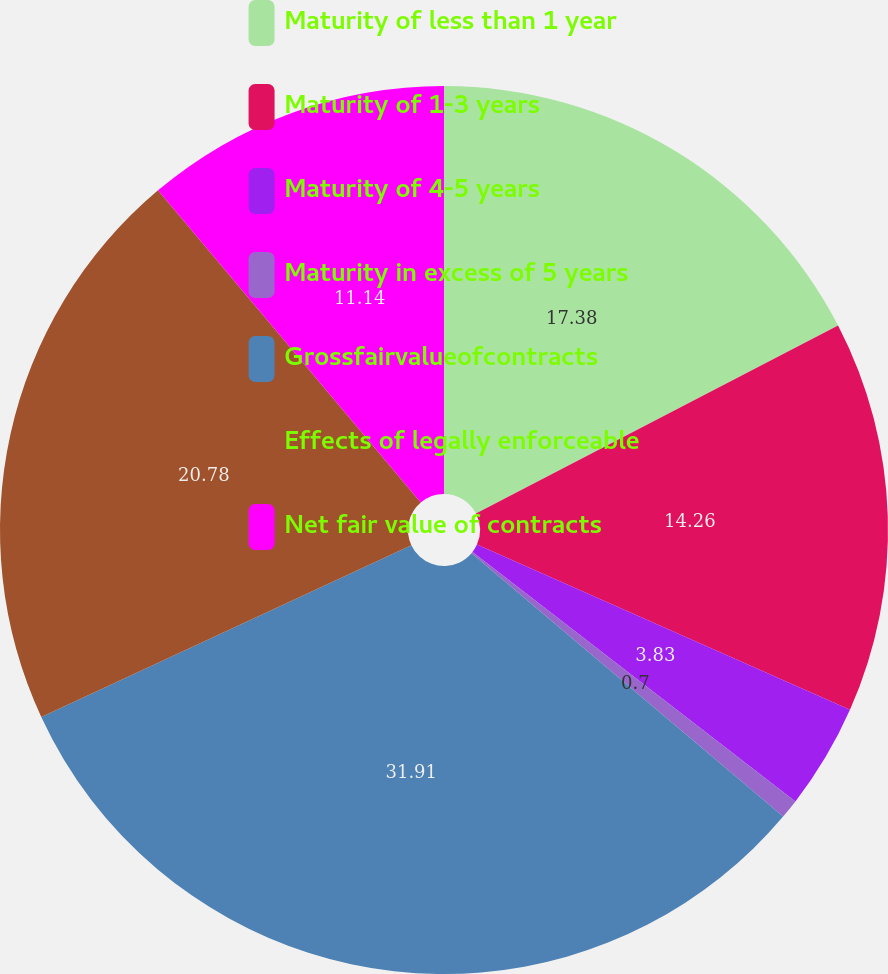Convert chart. <chart><loc_0><loc_0><loc_500><loc_500><pie_chart><fcel>Maturity of less than 1 year<fcel>Maturity of 1-3 years<fcel>Maturity of 4-5 years<fcel>Maturity in excess of 5 years<fcel>Grossfairvalueofcontracts<fcel>Effects of legally enforceable<fcel>Net fair value of contracts<nl><fcel>17.38%<fcel>14.26%<fcel>3.83%<fcel>0.7%<fcel>31.92%<fcel>20.78%<fcel>11.14%<nl></chart> 